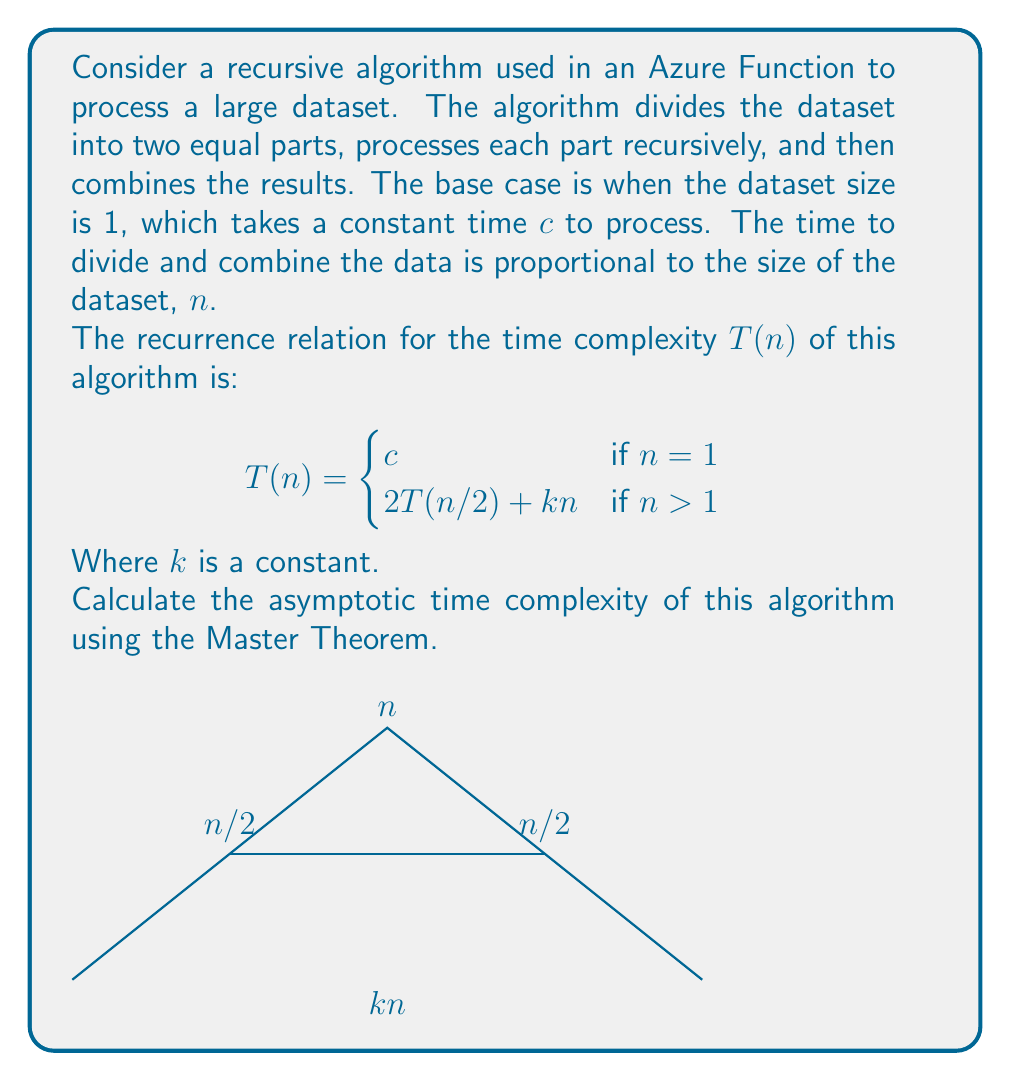Could you help me with this problem? To solve this problem, we'll use the Master Theorem, which is applicable for recurrences of the form:

$$T(n) = aT(n/b) + f(n)$$

Where $a \geq 1$, $b > 1$, and $f(n)$ is a positive function.

In our case:
$a = 2$ (number of recursive calls)
$b = 2$ (input size for each recursive call)
$f(n) = kn$ (work done outside the recursive calls)

Now, let's compare $n^{\log_b a}$ with $f(n)$:

1) Calculate $n^{\log_b a}$:
   $n^{\log_2 2} = n^1 = n$

2) Compare $n$ with $f(n) = kn$:
   $f(n) = \Theta(n)$

This matches Case 2 of the Master Theorem:
If $f(n) = \Theta(n^{\log_b a})$, then $T(n) = \Theta(n^{\log_b a} \log n)$

Therefore, $T(n) = \Theta(n \log n)$

This means that the time complexity of the algorithm grows as $n \log n$, which is slightly worse than linear time but better than quadratic time.
Answer: $\Theta(n \log n)$ 